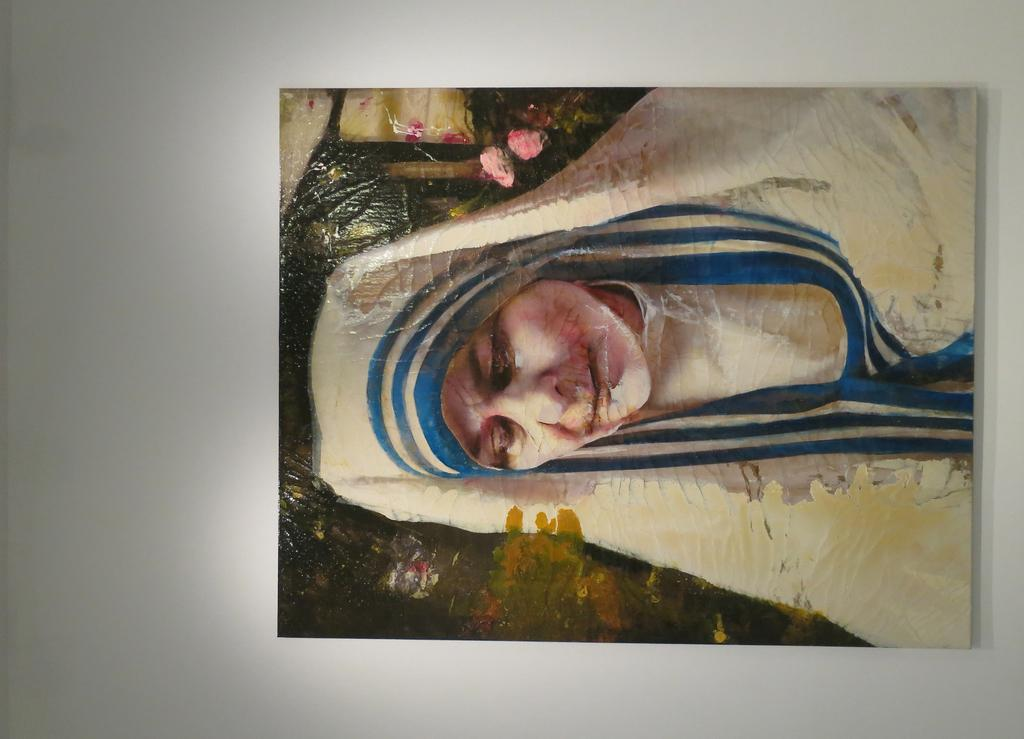What is depicted in the painting in the image? There is a painting of a woman in the image. What is the painting mounted on? The painting is on a board. What is the color of the object that the board is resting on? The board is on a white object. What type of crack can be seen in the painting? There is no crack visible in the painting; it appears to be undamaged. 